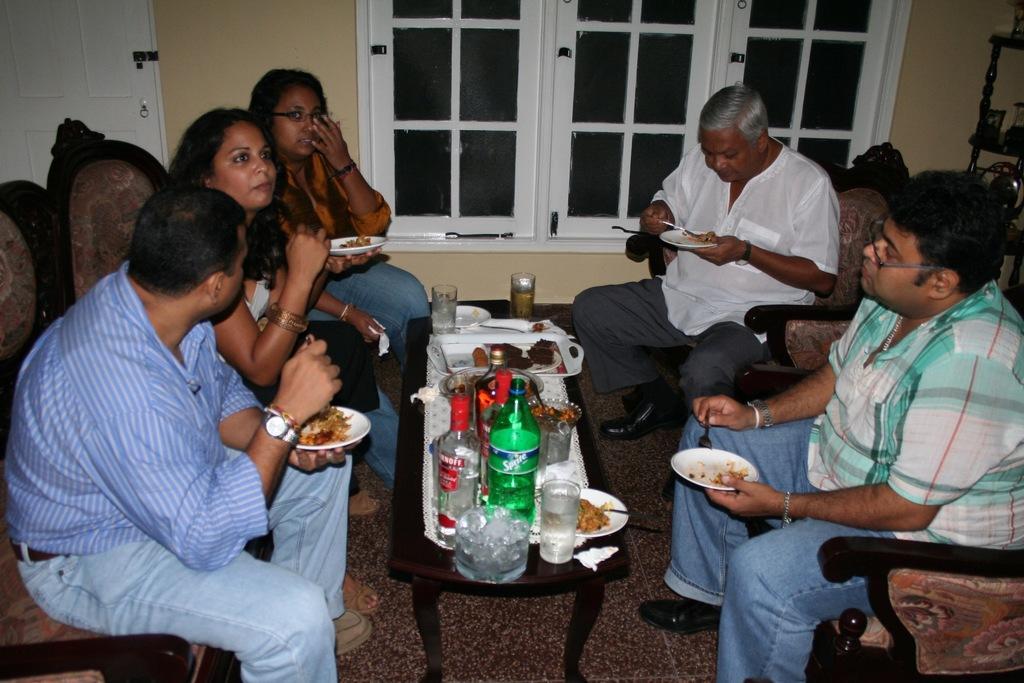Can you describe this image briefly? In this image i can see inside view of house. on the middle i can see a table. on the table there are some bottle ,there is a glass and there is plate an there is a food. on the glass there is a drink. and on the right side a person wearing a green color shirt and holding a plate,on the plate there is a food. right corner there is a person wearing a white color shirt and holding a plate. and on the left there are three persons sitting on the chair and there is a window on the back ground and on the right corner there is table. 